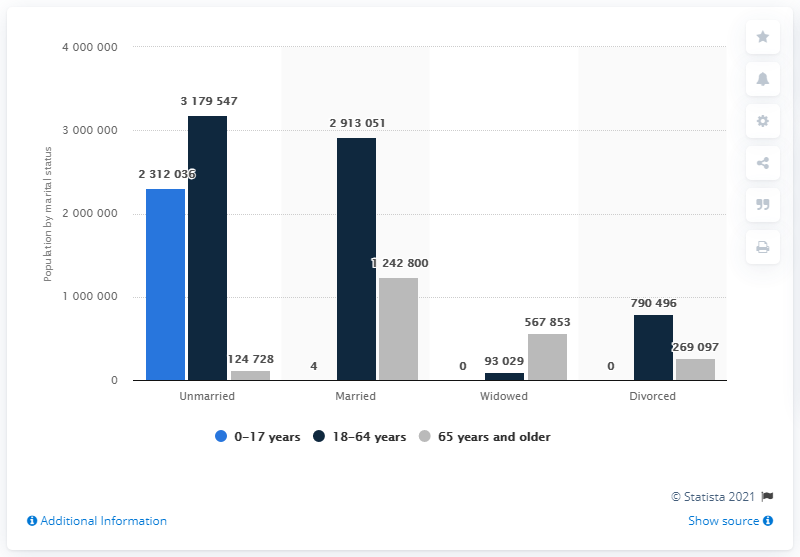Draw attention to some important aspects in this diagram. In 2020, in Belgium, the age group of people who were married included those who were 65 years old or older. 